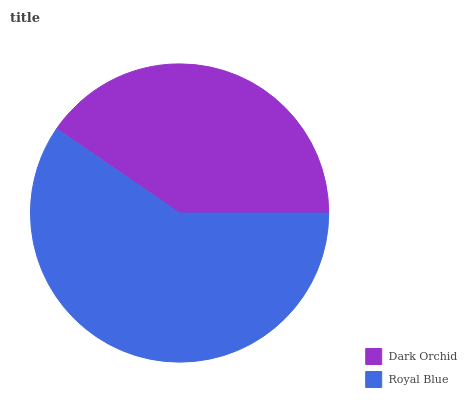Is Dark Orchid the minimum?
Answer yes or no. Yes. Is Royal Blue the maximum?
Answer yes or no. Yes. Is Royal Blue the minimum?
Answer yes or no. No. Is Royal Blue greater than Dark Orchid?
Answer yes or no. Yes. Is Dark Orchid less than Royal Blue?
Answer yes or no. Yes. Is Dark Orchid greater than Royal Blue?
Answer yes or no. No. Is Royal Blue less than Dark Orchid?
Answer yes or no. No. Is Royal Blue the high median?
Answer yes or no. Yes. Is Dark Orchid the low median?
Answer yes or no. Yes. Is Dark Orchid the high median?
Answer yes or no. No. Is Royal Blue the low median?
Answer yes or no. No. 